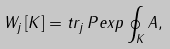<formula> <loc_0><loc_0><loc_500><loc_500>W _ { j } \, [ K ] = t r _ { j } \, P e x p \oint _ { K } A ,</formula> 